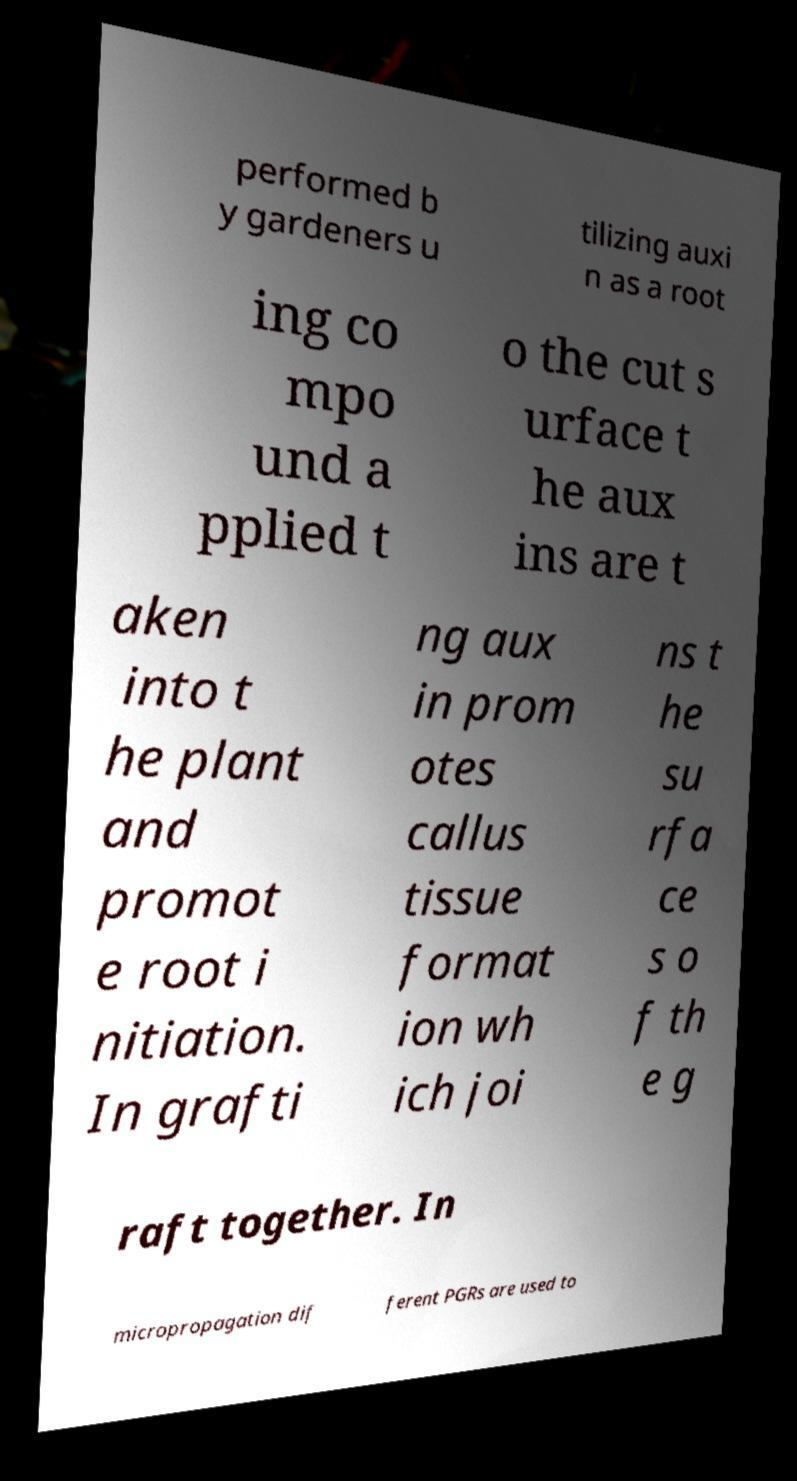Please identify and transcribe the text found in this image. performed b y gardeners u tilizing auxi n as a root ing co mpo und a pplied t o the cut s urface t he aux ins are t aken into t he plant and promot e root i nitiation. In grafti ng aux in prom otes callus tissue format ion wh ich joi ns t he su rfa ce s o f th e g raft together. In micropropagation dif ferent PGRs are used to 